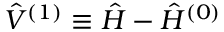Convert formula to latex. <formula><loc_0><loc_0><loc_500><loc_500>\hat { V } ^ { ( 1 ) } \equiv \hat { H } - \hat { H } ^ { ( 0 ) }</formula> 